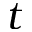<formula> <loc_0><loc_0><loc_500><loc_500>t</formula> 